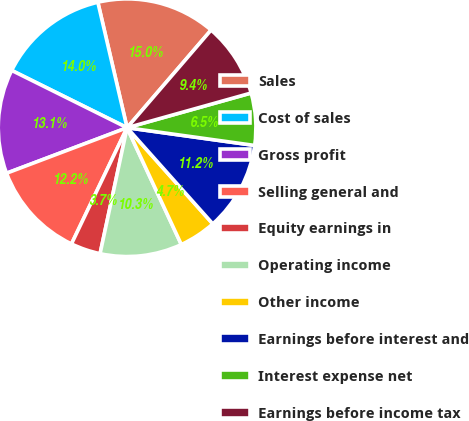Convert chart. <chart><loc_0><loc_0><loc_500><loc_500><pie_chart><fcel>Sales<fcel>Cost of sales<fcel>Gross profit<fcel>Selling general and<fcel>Equity earnings in<fcel>Operating income<fcel>Other income<fcel>Earnings before interest and<fcel>Interest expense net<fcel>Earnings before income tax<nl><fcel>14.95%<fcel>14.02%<fcel>13.08%<fcel>12.15%<fcel>3.74%<fcel>10.28%<fcel>4.67%<fcel>11.21%<fcel>6.54%<fcel>9.35%<nl></chart> 